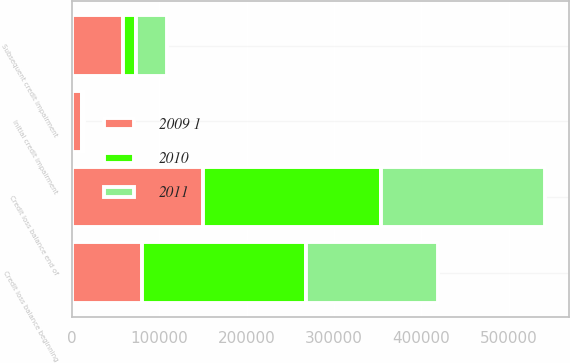Convert chart. <chart><loc_0><loc_0><loc_500><loc_500><stacked_bar_chart><ecel><fcel>Credit loss balance beginning<fcel>Initial credit impairment<fcel>Subsequent credit impairment<fcel>Credit loss balance end of<nl><fcel>2010<fcel>188038<fcel>61<fcel>14846<fcel>202945<nl><fcel>2011<fcel>150372<fcel>1642<fcel>36024<fcel>188038<nl><fcel>2009 1<fcel>80060<fcel>11780<fcel>58532<fcel>150372<nl></chart> 